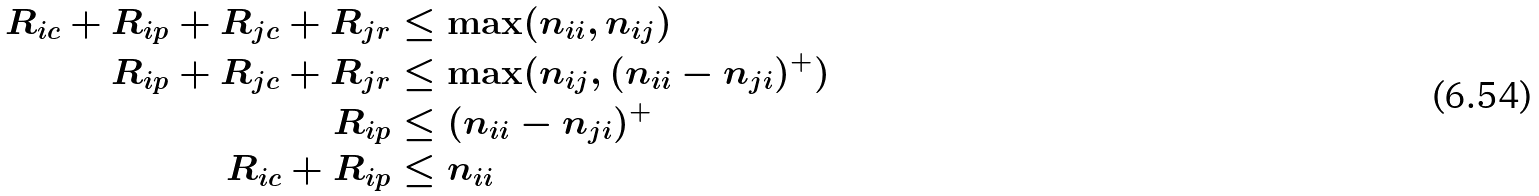Convert formula to latex. <formula><loc_0><loc_0><loc_500><loc_500>R _ { i c } + R _ { i p } + R _ { j c } + R _ { j r } & \leq \max ( n _ { i i } , n _ { i j } ) \\ R _ { i p } + R _ { j c } + R _ { j r } & \leq \max ( n _ { i j } , ( n _ { i i } - n _ { j i } ) ^ { + } ) \\ R _ { i p } & \leq ( n _ { i i } - n _ { j i } ) ^ { + } \\ R _ { i c } + R _ { i p } & \leq n _ { i i }</formula> 